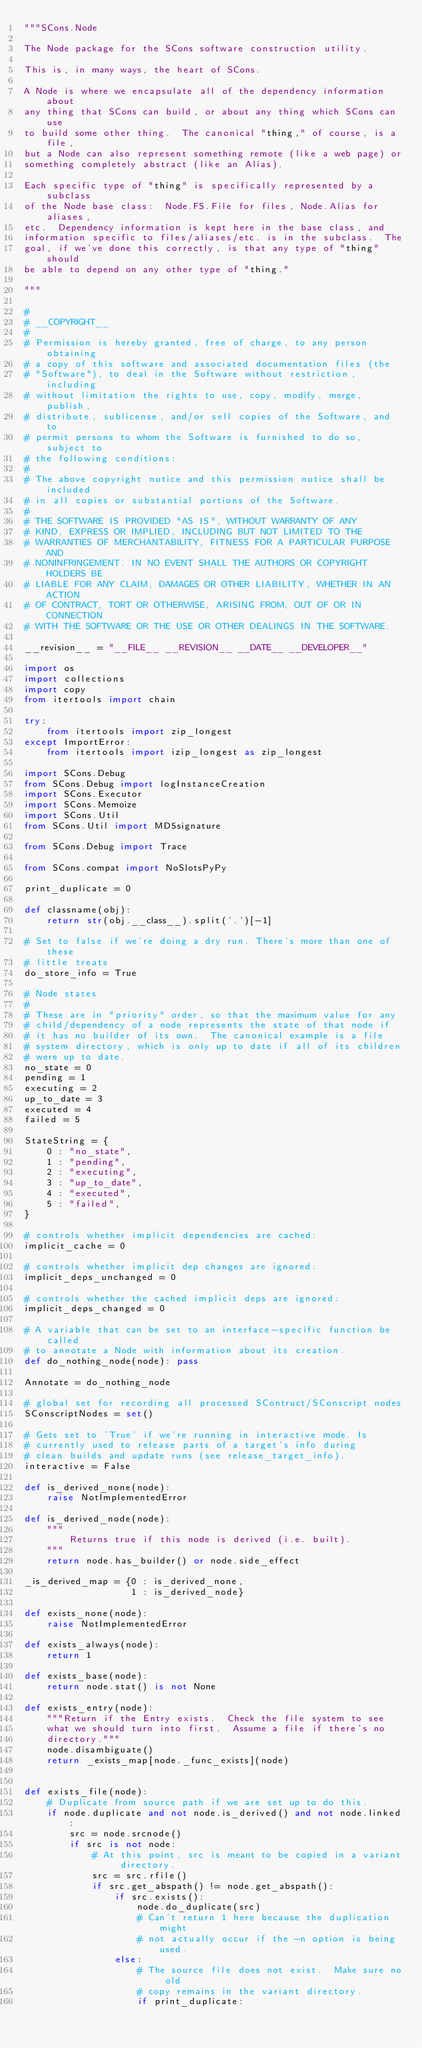<code> <loc_0><loc_0><loc_500><loc_500><_Python_>"""SCons.Node

The Node package for the SCons software construction utility.

This is, in many ways, the heart of SCons.

A Node is where we encapsulate all of the dependency information about
any thing that SCons can build, or about any thing which SCons can use
to build some other thing.  The canonical "thing," of course, is a file,
but a Node can also represent something remote (like a web page) or
something completely abstract (like an Alias).

Each specific type of "thing" is specifically represented by a subclass
of the Node base class:  Node.FS.File for files, Node.Alias for aliases,
etc.  Dependency information is kept here in the base class, and
information specific to files/aliases/etc. is in the subclass.  The
goal, if we've done this correctly, is that any type of "thing" should
be able to depend on any other type of "thing."

"""

#
# __COPYRIGHT__
#
# Permission is hereby granted, free of charge, to any person obtaining
# a copy of this software and associated documentation files (the
# "Software"), to deal in the Software without restriction, including
# without limitation the rights to use, copy, modify, merge, publish,
# distribute, sublicense, and/or sell copies of the Software, and to
# permit persons to whom the Software is furnished to do so, subject to
# the following conditions:
#
# The above copyright notice and this permission notice shall be included
# in all copies or substantial portions of the Software.
#
# THE SOFTWARE IS PROVIDED "AS IS", WITHOUT WARRANTY OF ANY
# KIND, EXPRESS OR IMPLIED, INCLUDING BUT NOT LIMITED TO THE
# WARRANTIES OF MERCHANTABILITY, FITNESS FOR A PARTICULAR PURPOSE AND
# NONINFRINGEMENT. IN NO EVENT SHALL THE AUTHORS OR COPYRIGHT HOLDERS BE
# LIABLE FOR ANY CLAIM, DAMAGES OR OTHER LIABILITY, WHETHER IN AN ACTION
# OF CONTRACT, TORT OR OTHERWISE, ARISING FROM, OUT OF OR IN CONNECTION
# WITH THE SOFTWARE OR THE USE OR OTHER DEALINGS IN THE SOFTWARE.

__revision__ = "__FILE__ __REVISION__ __DATE__ __DEVELOPER__"

import os
import collections
import copy
from itertools import chain

try:
    from itertools import zip_longest
except ImportError:
    from itertools import izip_longest as zip_longest

import SCons.Debug
from SCons.Debug import logInstanceCreation
import SCons.Executor
import SCons.Memoize
import SCons.Util
from SCons.Util import MD5signature

from SCons.Debug import Trace

from SCons.compat import NoSlotsPyPy

print_duplicate = 0

def classname(obj):
    return str(obj.__class__).split('.')[-1]

# Set to false if we're doing a dry run. There's more than one of these
# little treats
do_store_info = True

# Node states
#
# These are in "priority" order, so that the maximum value for any
# child/dependency of a node represents the state of that node if
# it has no builder of its own.  The canonical example is a file
# system directory, which is only up to date if all of its children
# were up to date.
no_state = 0
pending = 1
executing = 2
up_to_date = 3
executed = 4
failed = 5

StateString = {
    0 : "no_state",
    1 : "pending",
    2 : "executing",
    3 : "up_to_date",
    4 : "executed",
    5 : "failed",
}

# controls whether implicit dependencies are cached:
implicit_cache = 0

# controls whether implicit dep changes are ignored:
implicit_deps_unchanged = 0

# controls whether the cached implicit deps are ignored:
implicit_deps_changed = 0

# A variable that can be set to an interface-specific function be called
# to annotate a Node with information about its creation.
def do_nothing_node(node): pass

Annotate = do_nothing_node

# global set for recording all processed SContruct/SConscript nodes
SConscriptNodes = set()

# Gets set to 'True' if we're running in interactive mode. Is
# currently used to release parts of a target's info during
# clean builds and update runs (see release_target_info).
interactive = False

def is_derived_none(node):
    raise NotImplementedError

def is_derived_node(node):
    """
        Returns true if this node is derived (i.e. built).
    """
    return node.has_builder() or node.side_effect

_is_derived_map = {0 : is_derived_none,
                   1 : is_derived_node}

def exists_none(node):
    raise NotImplementedError

def exists_always(node):
    return 1

def exists_base(node):
    return node.stat() is not None

def exists_entry(node):
    """Return if the Entry exists.  Check the file system to see
    what we should turn into first.  Assume a file if there's no
    directory."""
    node.disambiguate()
    return _exists_map[node._func_exists](node)


def exists_file(node):
    # Duplicate from source path if we are set up to do this.
    if node.duplicate and not node.is_derived() and not node.linked:
        src = node.srcnode()
        if src is not node:
            # At this point, src is meant to be copied in a variant directory.
            src = src.rfile()
            if src.get_abspath() != node.get_abspath():
                if src.exists():
                    node.do_duplicate(src)
                    # Can't return 1 here because the duplication might
                    # not actually occur if the -n option is being used.
                else:
                    # The source file does not exist.  Make sure no old
                    # copy remains in the variant directory.
                    if print_duplicate:</code> 